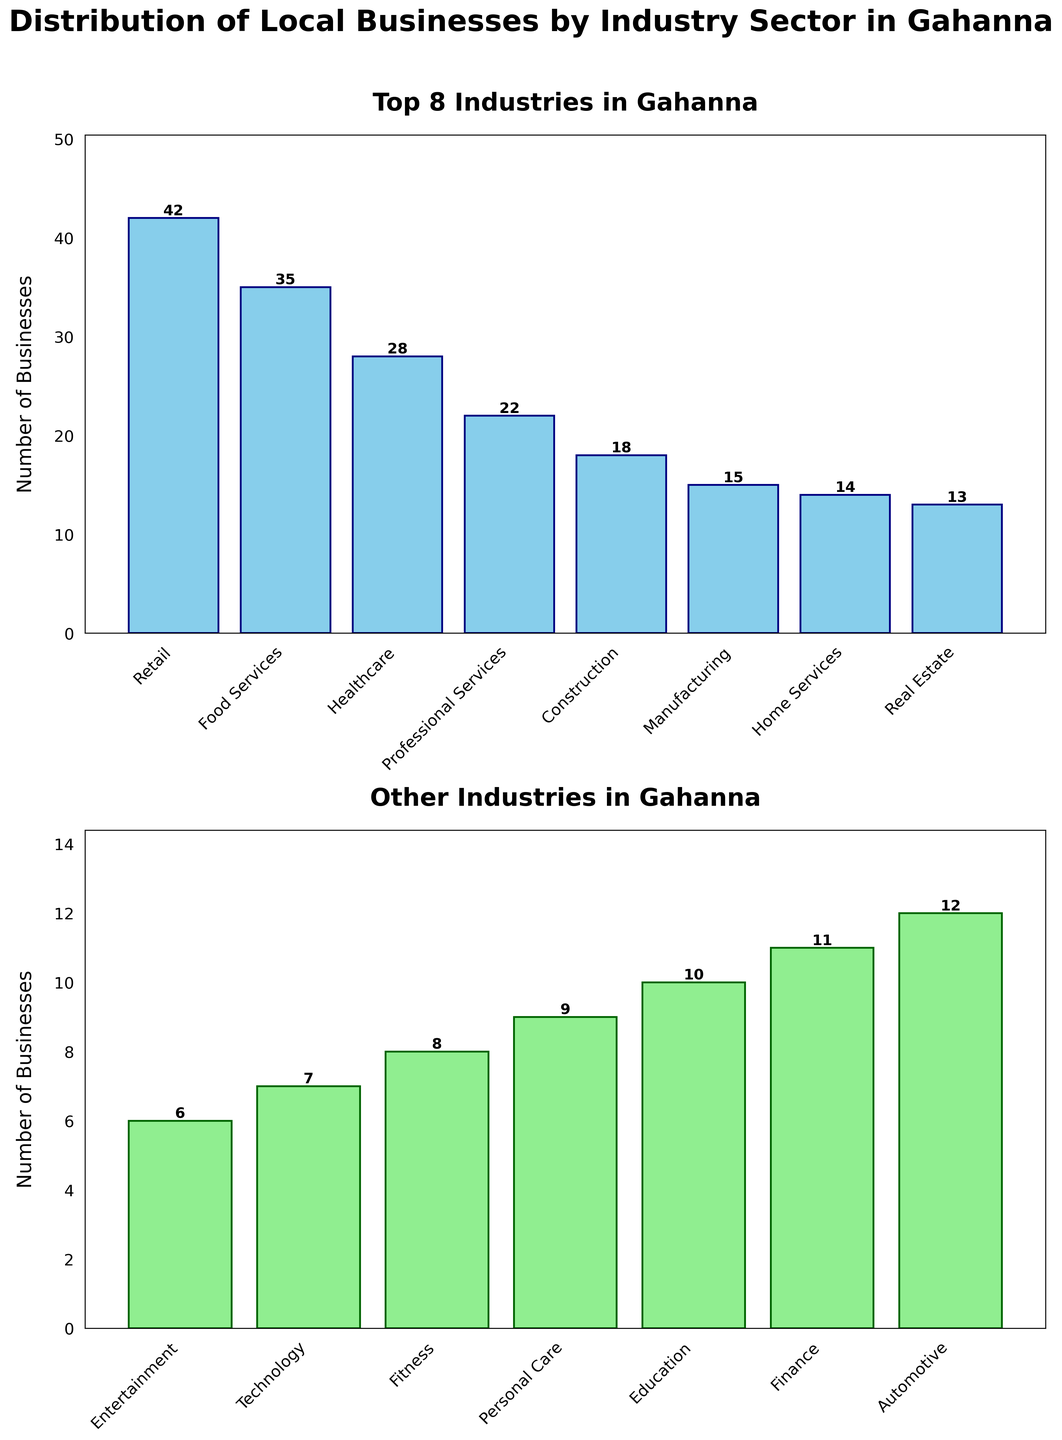Which industry has the highest number of businesses in Gahanna? According to the first subplot, Retail has the tallest bar, indicating it has the highest number of businesses.
Answer: Retail How many businesses are in the Food Services sector? In the first subplot, the bar for Food Services has a height labeled as 35.
Answer: 35 What is the title of the second subplot? The title of the second subplot is displayed at the top of the lower bar chart: "Other Industries in Gahanna".
Answer: Other Industries in Gahanna Which industry has the fewest businesses? Observing the second subplot, the shortest bar corresponds to Entertainment, meaning it has the fewest businesses.
Answer: Entertainment How many businesses are listed among the top 8 industries? Summing the heights of the bars in the first subplot: 42 (Retail) + 35 (Food Services) + 28 (Healthcare) + 22 (Professional Services) + 18 (Construction) + 15 (Manufacturing) + 14 (Home Services) + 13 (Real Estate) = 187
Answer: 187 What's the difference in the number of businesses between the Healthcare and the Fitness sectors? Healthcare has 28 businesses, and Fitness has 8 businesses. The difference is calculated as 28 - 8 = 20.
Answer: 20 Which industry just exceeds 20 businesses but is not in the top 3? The bar for Professional Services in the first subplot has a height labeled as 22, which is just above 20 and is not in the top 3.
Answer: Professional Services Which bar in the second subplot represents the Finance sector, and how many businesses does it have? In the second subplot, the bar for Finance is individually labeled with 11 businesses.
Answer: Finance, 11 How many more businesses are there in the Retail sector than in the Automotive sector? Retail has 42 businesses, while Automotive has 12 businesses. The difference is 42 - 12 = 30.
Answer: 30 What is the combined number of businesses in the Construction and Home Services sectors? Construction has 18 businesses, and Home Services have 14 businesses. Their combined number is 18 + 14 = 32.
Answer: 32 